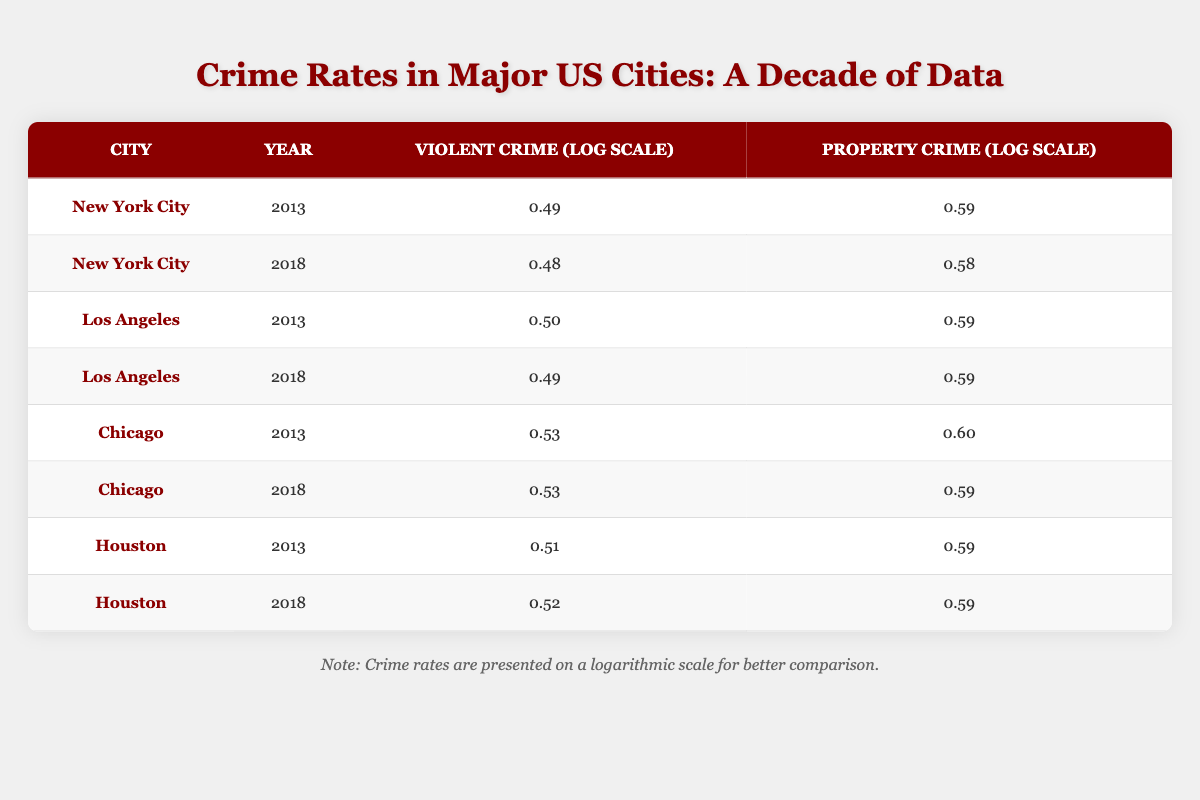What was the violent crime log value in Los Angeles in 2013? The table shows that in Los Angeles, the violent crime log value for the year 2013 is 3.18.
Answer: 3.18 What is the difference in property crime log values between New York City in 2013 and 2018? In New York City, the property crime log value in 2013 is 3.85 and in 2018 it is 3.79. The difference is 3.85 - 3.79 = 0.06.
Answer: 0.06 Is it true that Houston had a higher violent crime log value than Chicago in 2018? In 2018, Houston's violent crime log value is 3.30 while Chicago's is 3.36. Since 3.30 is less than 3.36, the statement is false.
Answer: No What was the average violent crime log value for all cities in 2018? The violent crime log values for the year 2018 are 2.99 (New York City), 3.11 (Los Angeles), 3.36 (Chicago), and 3.30 (Houston). The total is 2.99 + 3.11 + 3.36 + 3.30 = 12.76, and dividing by 4 cities gives an average of 12.76 / 4 = 3.19.
Answer: 3.19 Which city had the highest property crime log value in the year 2013? Looking at the property crime log values for 2013, New York City has 3.85, Los Angeles has 3.90, Chicago has 3.95, and Houston has 3.85. Chicago has the highest value of 3.95 in 2013.
Answer: Chicago 